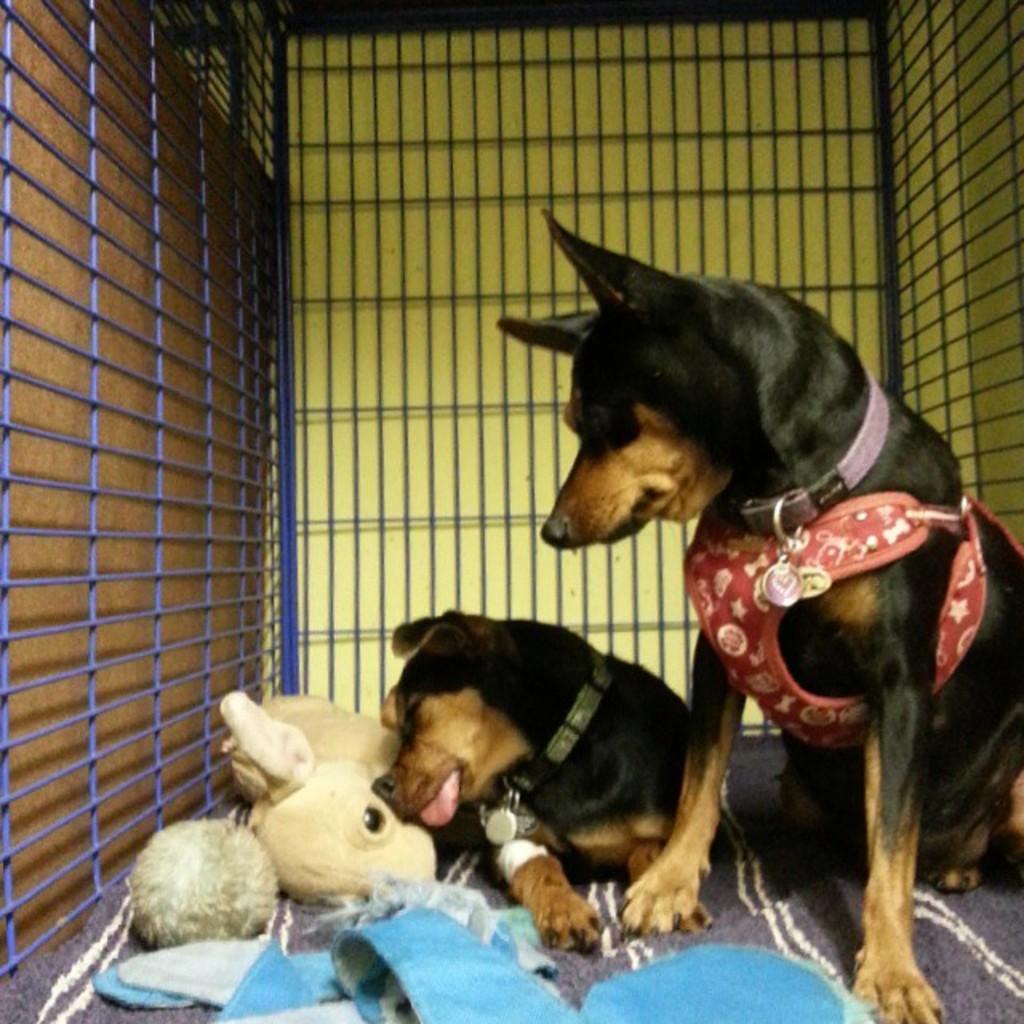Can you describe this image briefly? In this image I can see 2 dogs in a cage. There are belts in their necks and there is a soft toy. 